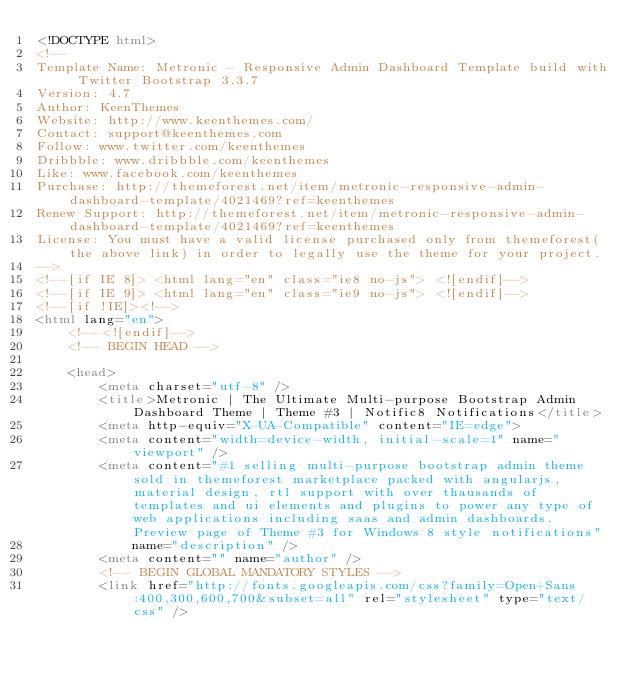<code> <loc_0><loc_0><loc_500><loc_500><_HTML_><!DOCTYPE html>
<!-- 
Template Name: Metronic - Responsive Admin Dashboard Template build with Twitter Bootstrap 3.3.7
Version: 4.7
Author: KeenThemes
Website: http://www.keenthemes.com/
Contact: support@keenthemes.com
Follow: www.twitter.com/keenthemes
Dribbble: www.dribbble.com/keenthemes
Like: www.facebook.com/keenthemes
Purchase: http://themeforest.net/item/metronic-responsive-admin-dashboard-template/4021469?ref=keenthemes
Renew Support: http://themeforest.net/item/metronic-responsive-admin-dashboard-template/4021469?ref=keenthemes
License: You must have a valid license purchased only from themeforest(the above link) in order to legally use the theme for your project.
-->
<!--[if IE 8]> <html lang="en" class="ie8 no-js"> <![endif]-->
<!--[if IE 9]> <html lang="en" class="ie9 no-js"> <![endif]-->
<!--[if !IE]><!-->
<html lang="en">
    <!--<![endif]-->
    <!-- BEGIN HEAD -->

    <head>
        <meta charset="utf-8" />
        <title>Metronic | The Ultimate Multi-purpose Bootstrap Admin Dashboard Theme | Theme #3 | Notific8 Notifications</title>
        <meta http-equiv="X-UA-Compatible" content="IE=edge">
        <meta content="width=device-width, initial-scale=1" name="viewport" />
        <meta content="#1 selling multi-purpose bootstrap admin theme sold in themeforest marketplace packed with angularjs, material design, rtl support with over thausands of templates and ui elements and plugins to power any type of web applications including saas and admin dashboards. Preview page of Theme #3 for Windows 8 style notifications"
            name="description" />
        <meta content="" name="author" />
        <!-- BEGIN GLOBAL MANDATORY STYLES -->
        <link href="http://fonts.googleapis.com/css?family=Open+Sans:400,300,600,700&subset=all" rel="stylesheet" type="text/css" /></code> 